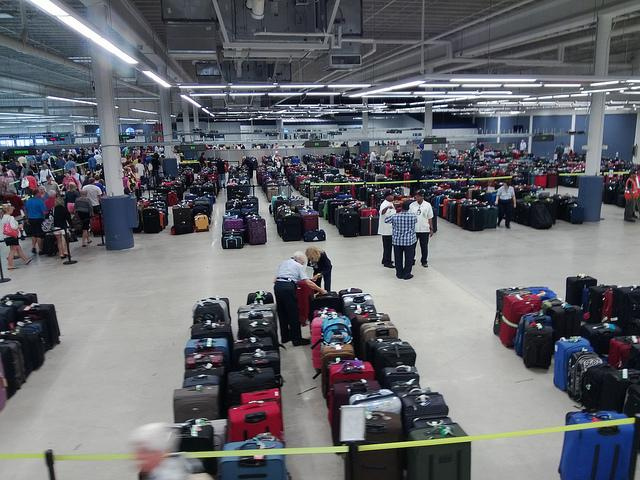What color is the tape fence around the luggage area where there is a number of luggage bags? Please explain your reasoning. yellow. The tape is colored yellow. 